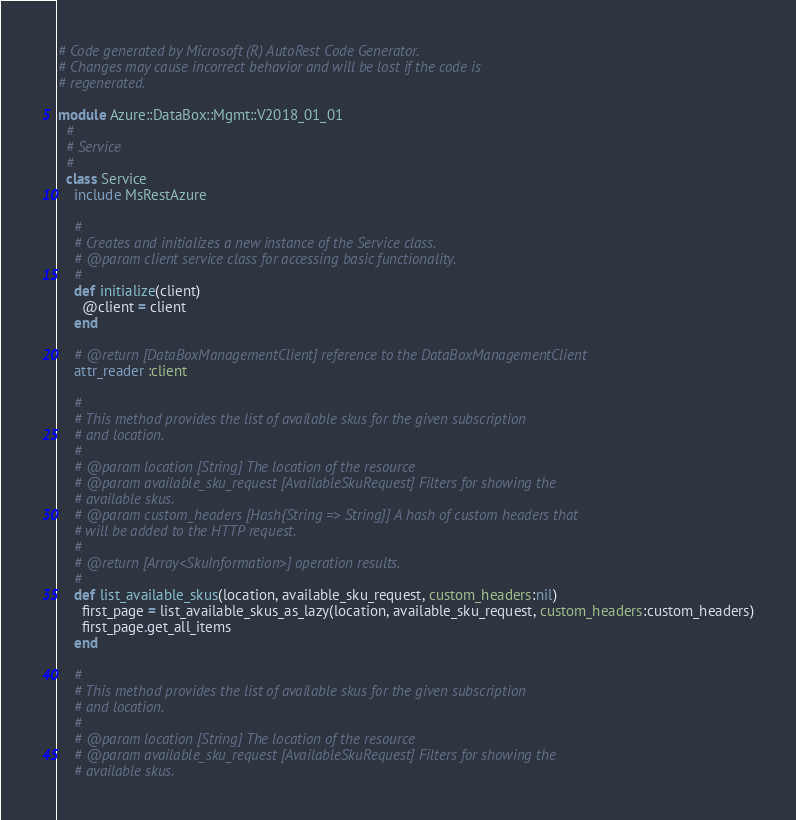<code> <loc_0><loc_0><loc_500><loc_500><_Ruby_># Code generated by Microsoft (R) AutoRest Code Generator.
# Changes may cause incorrect behavior and will be lost if the code is
# regenerated.

module Azure::DataBox::Mgmt::V2018_01_01
  #
  # Service
  #
  class Service
    include MsRestAzure

    #
    # Creates and initializes a new instance of the Service class.
    # @param client service class for accessing basic functionality.
    #
    def initialize(client)
      @client = client
    end

    # @return [DataBoxManagementClient] reference to the DataBoxManagementClient
    attr_reader :client

    #
    # This method provides the list of available skus for the given subscription
    # and location.
    #
    # @param location [String] The location of the resource
    # @param available_sku_request [AvailableSkuRequest] Filters for showing the
    # available skus.
    # @param custom_headers [Hash{String => String}] A hash of custom headers that
    # will be added to the HTTP request.
    #
    # @return [Array<SkuInformation>] operation results.
    #
    def list_available_skus(location, available_sku_request, custom_headers:nil)
      first_page = list_available_skus_as_lazy(location, available_sku_request, custom_headers:custom_headers)
      first_page.get_all_items
    end

    #
    # This method provides the list of available skus for the given subscription
    # and location.
    #
    # @param location [String] The location of the resource
    # @param available_sku_request [AvailableSkuRequest] Filters for showing the
    # available skus.</code> 